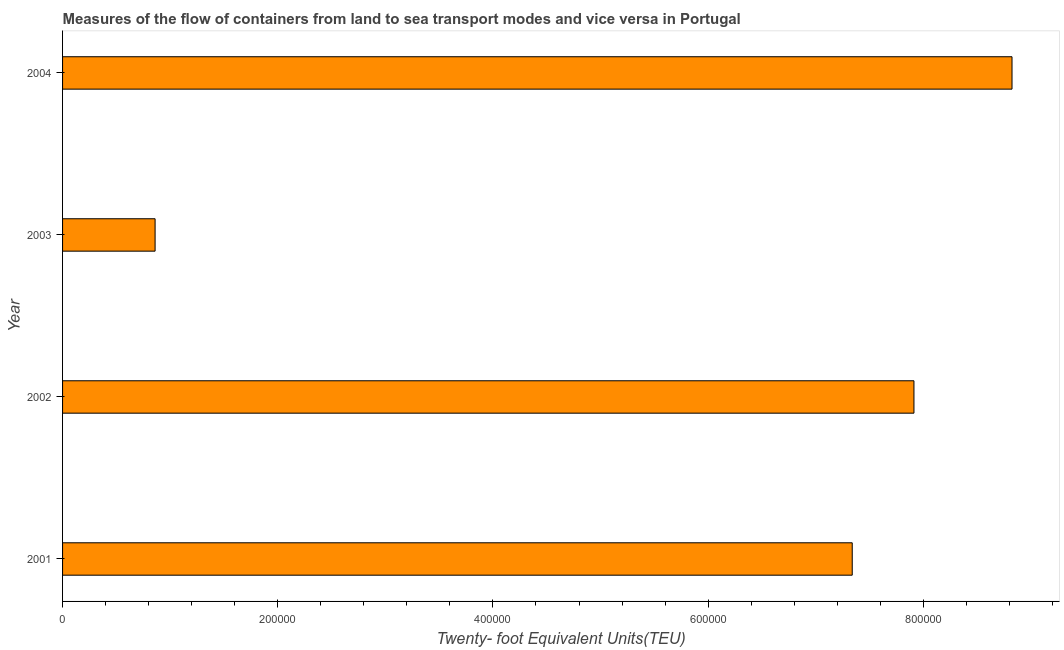What is the title of the graph?
Your response must be concise. Measures of the flow of containers from land to sea transport modes and vice versa in Portugal. What is the label or title of the X-axis?
Provide a succinct answer. Twenty- foot Equivalent Units(TEU). What is the label or title of the Y-axis?
Offer a terse response. Year. What is the container port traffic in 2002?
Offer a terse response. 7.91e+05. Across all years, what is the maximum container port traffic?
Offer a terse response. 8.82e+05. Across all years, what is the minimum container port traffic?
Provide a succinct answer. 8.60e+04. In which year was the container port traffic minimum?
Your answer should be very brief. 2003. What is the sum of the container port traffic?
Make the answer very short. 2.49e+06. What is the difference between the container port traffic in 2001 and 2004?
Make the answer very short. -1.49e+05. What is the average container port traffic per year?
Give a very brief answer. 6.23e+05. What is the median container port traffic?
Give a very brief answer. 7.63e+05. In how many years, is the container port traffic greater than 480000 TEU?
Provide a succinct answer. 3. Do a majority of the years between 2002 and 2004 (inclusive) have container port traffic greater than 640000 TEU?
Make the answer very short. Yes. What is the ratio of the container port traffic in 2002 to that in 2003?
Your answer should be compact. 9.2. Is the container port traffic in 2002 less than that in 2004?
Make the answer very short. Yes. Is the difference between the container port traffic in 2001 and 2002 greater than the difference between any two years?
Give a very brief answer. No. What is the difference between the highest and the second highest container port traffic?
Keep it short and to the point. 9.12e+04. What is the difference between the highest and the lowest container port traffic?
Make the answer very short. 7.96e+05. How many bars are there?
Provide a succinct answer. 4. Are all the bars in the graph horizontal?
Provide a succinct answer. Yes. How many years are there in the graph?
Keep it short and to the point. 4. Are the values on the major ticks of X-axis written in scientific E-notation?
Make the answer very short. No. What is the Twenty- foot Equivalent Units(TEU) of 2001?
Provide a short and direct response. 7.34e+05. What is the Twenty- foot Equivalent Units(TEU) of 2002?
Your response must be concise. 7.91e+05. What is the Twenty- foot Equivalent Units(TEU) of 2003?
Provide a succinct answer. 8.60e+04. What is the Twenty- foot Equivalent Units(TEU) in 2004?
Your response must be concise. 8.82e+05. What is the difference between the Twenty- foot Equivalent Units(TEU) in 2001 and 2002?
Provide a short and direct response. -5.74e+04. What is the difference between the Twenty- foot Equivalent Units(TEU) in 2001 and 2003?
Offer a terse response. 6.48e+05. What is the difference between the Twenty- foot Equivalent Units(TEU) in 2001 and 2004?
Your answer should be very brief. -1.49e+05. What is the difference between the Twenty- foot Equivalent Units(TEU) in 2002 and 2003?
Make the answer very short. 7.05e+05. What is the difference between the Twenty- foot Equivalent Units(TEU) in 2002 and 2004?
Offer a terse response. -9.12e+04. What is the difference between the Twenty- foot Equivalent Units(TEU) in 2003 and 2004?
Offer a very short reply. -7.96e+05. What is the ratio of the Twenty- foot Equivalent Units(TEU) in 2001 to that in 2002?
Make the answer very short. 0.93. What is the ratio of the Twenty- foot Equivalent Units(TEU) in 2001 to that in 2003?
Your response must be concise. 8.53. What is the ratio of the Twenty- foot Equivalent Units(TEU) in 2001 to that in 2004?
Make the answer very short. 0.83. What is the ratio of the Twenty- foot Equivalent Units(TEU) in 2002 to that in 2003?
Ensure brevity in your answer.  9.2. What is the ratio of the Twenty- foot Equivalent Units(TEU) in 2002 to that in 2004?
Offer a terse response. 0.9. What is the ratio of the Twenty- foot Equivalent Units(TEU) in 2003 to that in 2004?
Provide a short and direct response. 0.1. 